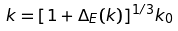<formula> <loc_0><loc_0><loc_500><loc_500>k = [ 1 + \Delta _ { E } ( k ) ] ^ { 1 / 3 } k _ { 0 }</formula> 